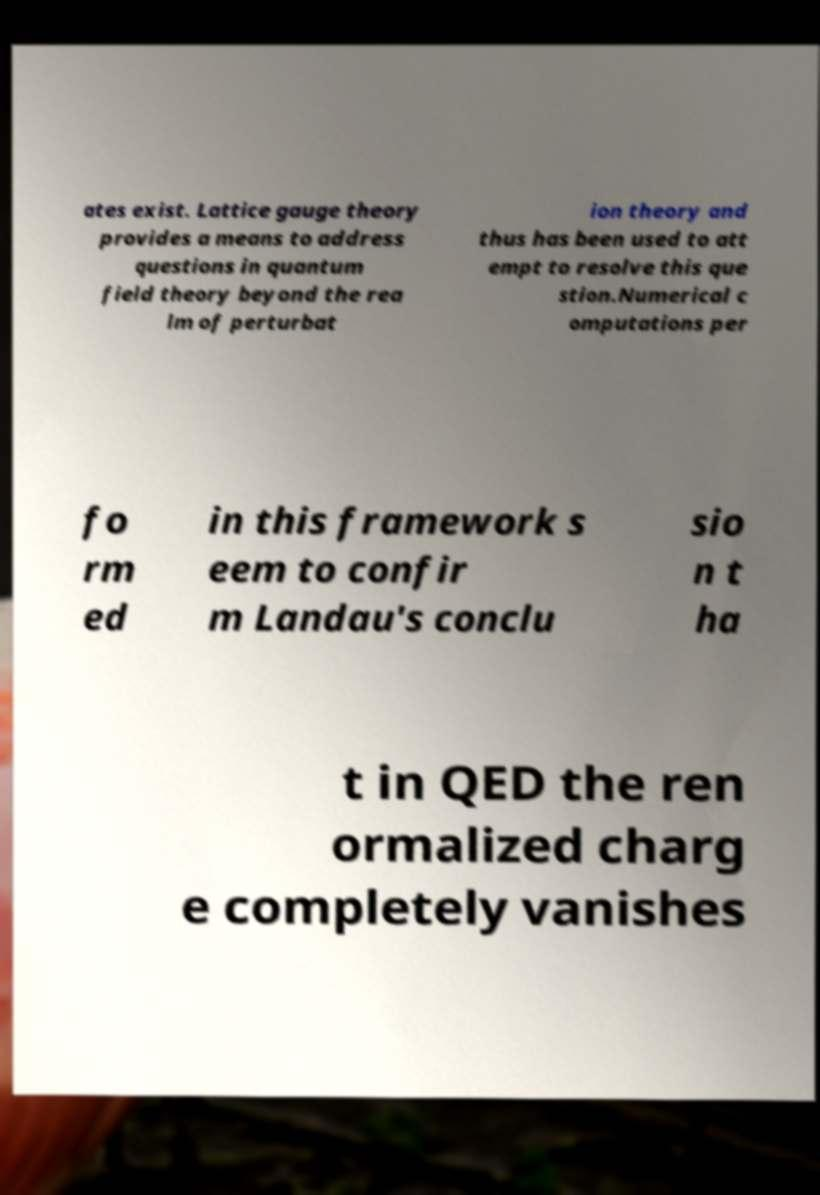I need the written content from this picture converted into text. Can you do that? ates exist. Lattice gauge theory provides a means to address questions in quantum field theory beyond the rea lm of perturbat ion theory and thus has been used to att empt to resolve this que stion.Numerical c omputations per fo rm ed in this framework s eem to confir m Landau's conclu sio n t ha t in QED the ren ormalized charg e completely vanishes 